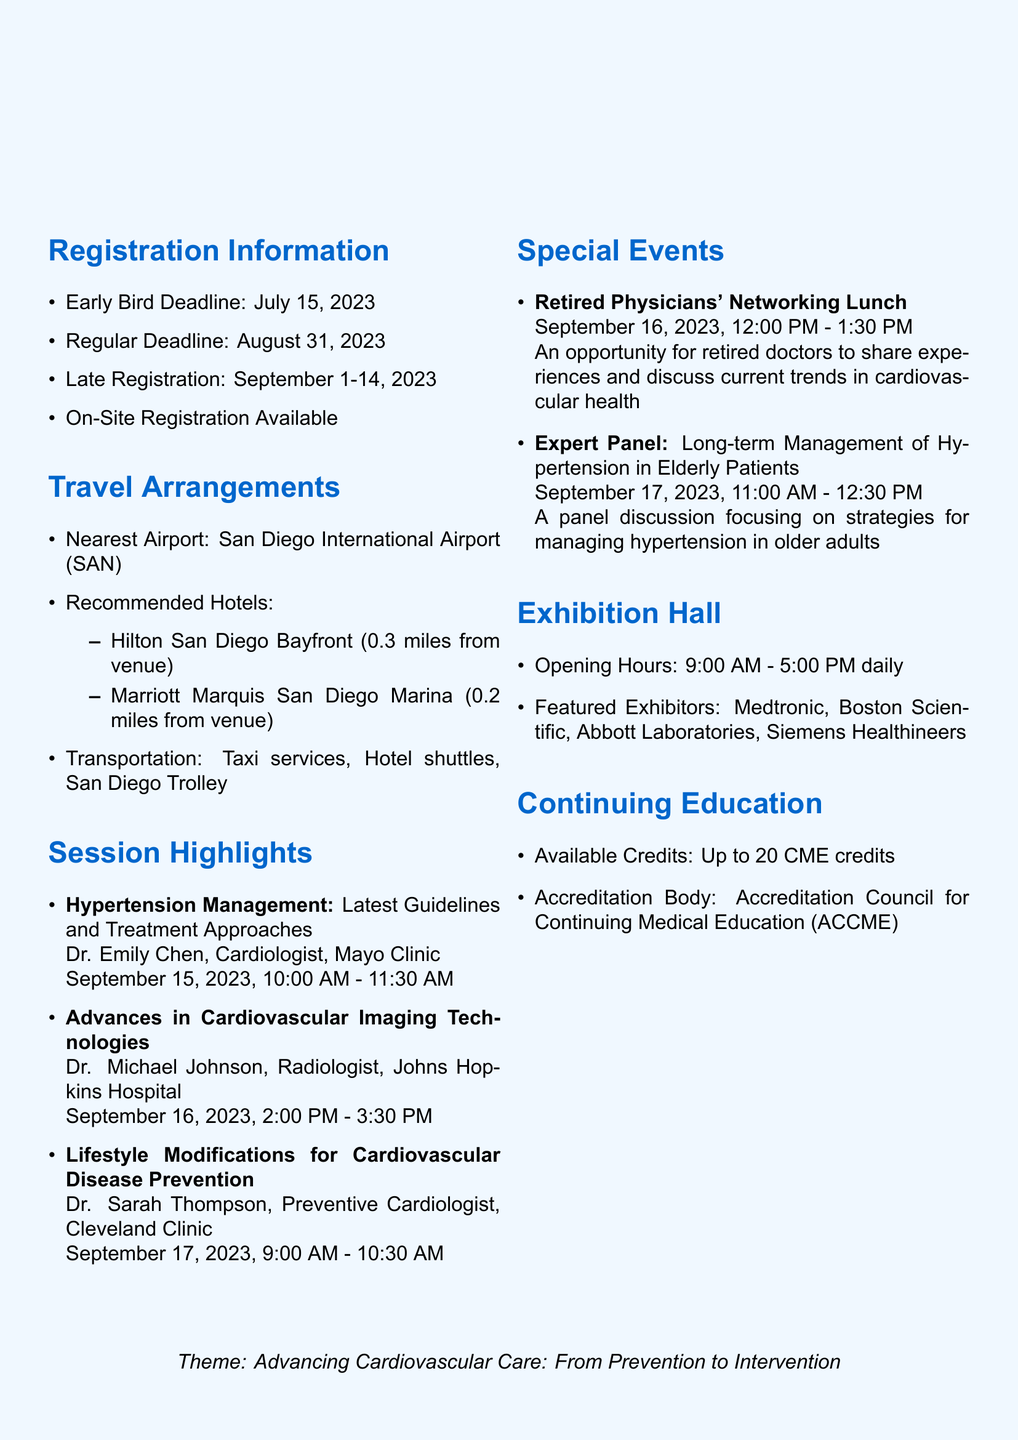What are the conference dates? The document states that the conference will take place from September 15 to 17, 2023.
Answer: September 15-17, 2023 What is the theme of the conference? The theme is mentioned in the document as "Advancing Cardiovascular Care: From Prevention to Intervention."
Answer: Advancing Cardiovascular Care: From Prevention to Intervention Who is the speaker for the hypertension management session? The session details specify that Dr. Emily Chen from the Mayo Clinic is the speaker for this session.
Answer: Dr. Emily Chen What is the deadline for early bird registration? The document provides the early bird registration deadline as July 15, 2023.
Answer: July 15, 2023 What time is the Expert Panel on hypertension? The Expert Panel discussion is scheduled to take place from 11:00 AM to 12:30 PM on September 17, 2023.
Answer: 11:00 AM - 12:30 PM Which hotel is closest to the venue? The document lists recommended hotels, with Marriott Marquis San Diego Marina being 0.2 miles from the venue, making it the closest.
Answer: Marriott Marquis San Diego Marina What is the maximum CME credit available? According to the continuing education section, participants can earn up to 20 CME credits.
Answer: Up to 20 CME credits When is the Retired Physicians' Networking Lunch scheduled? The document specifies that the networking lunch will take place on September 16, 2023, from 12:00 PM to 1:30 PM.
Answer: September 16, 2023, 12:00 PM - 1:30 PM 